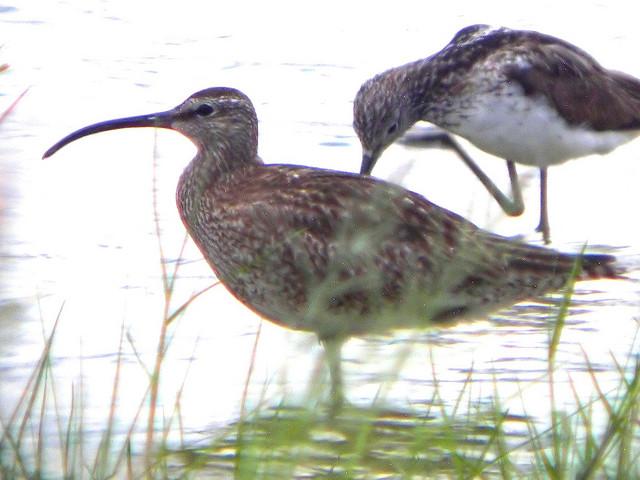What type of birds are they?
Be succinct. Seagull. Are the birds kissing?
Quick response, please. No. What are these birds doing?
Concise answer only. Wading. 